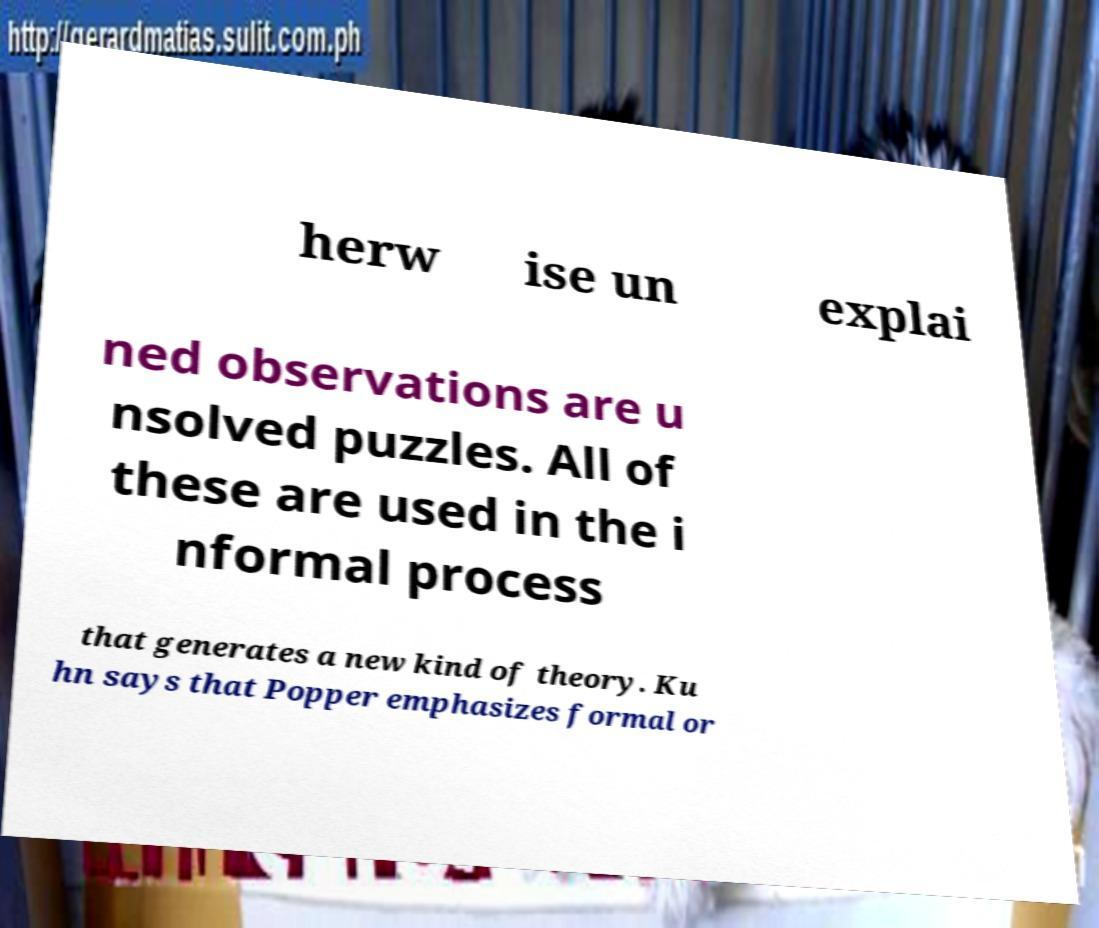What messages or text are displayed in this image? I need them in a readable, typed format. herw ise un explai ned observations are u nsolved puzzles. All of these are used in the i nformal process that generates a new kind of theory. Ku hn says that Popper emphasizes formal or 